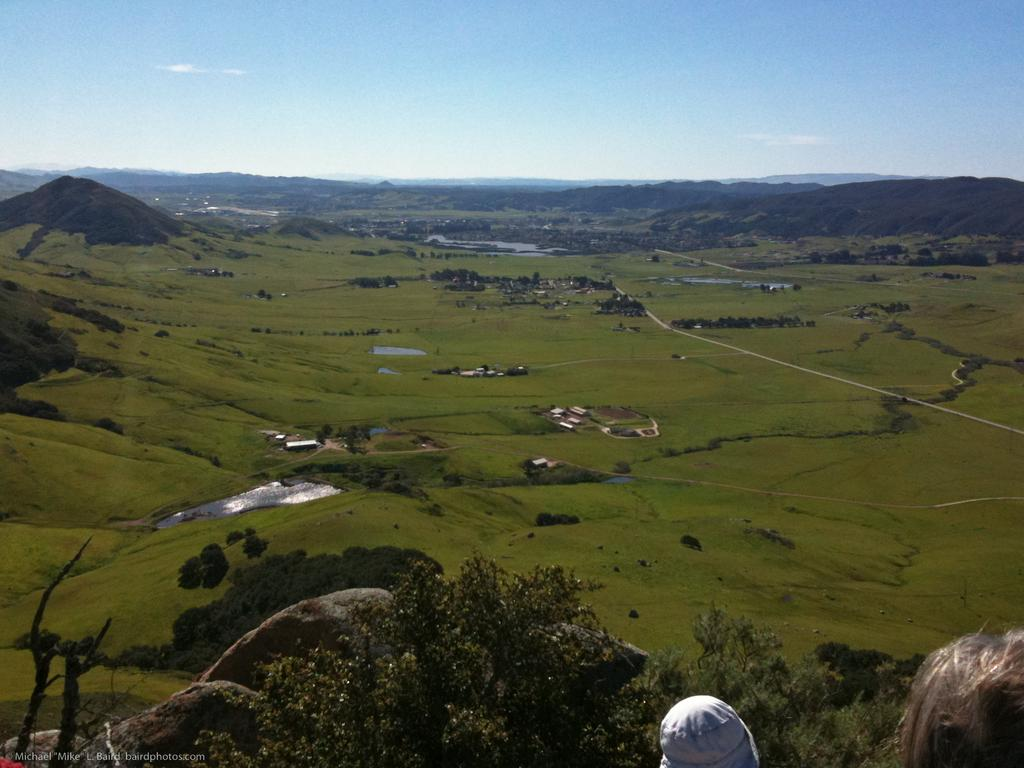What type of vegetation is in the front of the image? There are trees and rocks in the front of the image. What type of structures can be seen in the background of the image? There are houses in the background of the image. What type of vegetation is in the background of the image? There are trees and grass in the background of the image. What type of geographical feature is in the background of the image? There is a hill in the background of the image. What is visible at the top of the image? The sky is visible at the top of the image. Where is the farmer with the doll and linen in the image? There is no farmer, doll, or linen present in the image. 